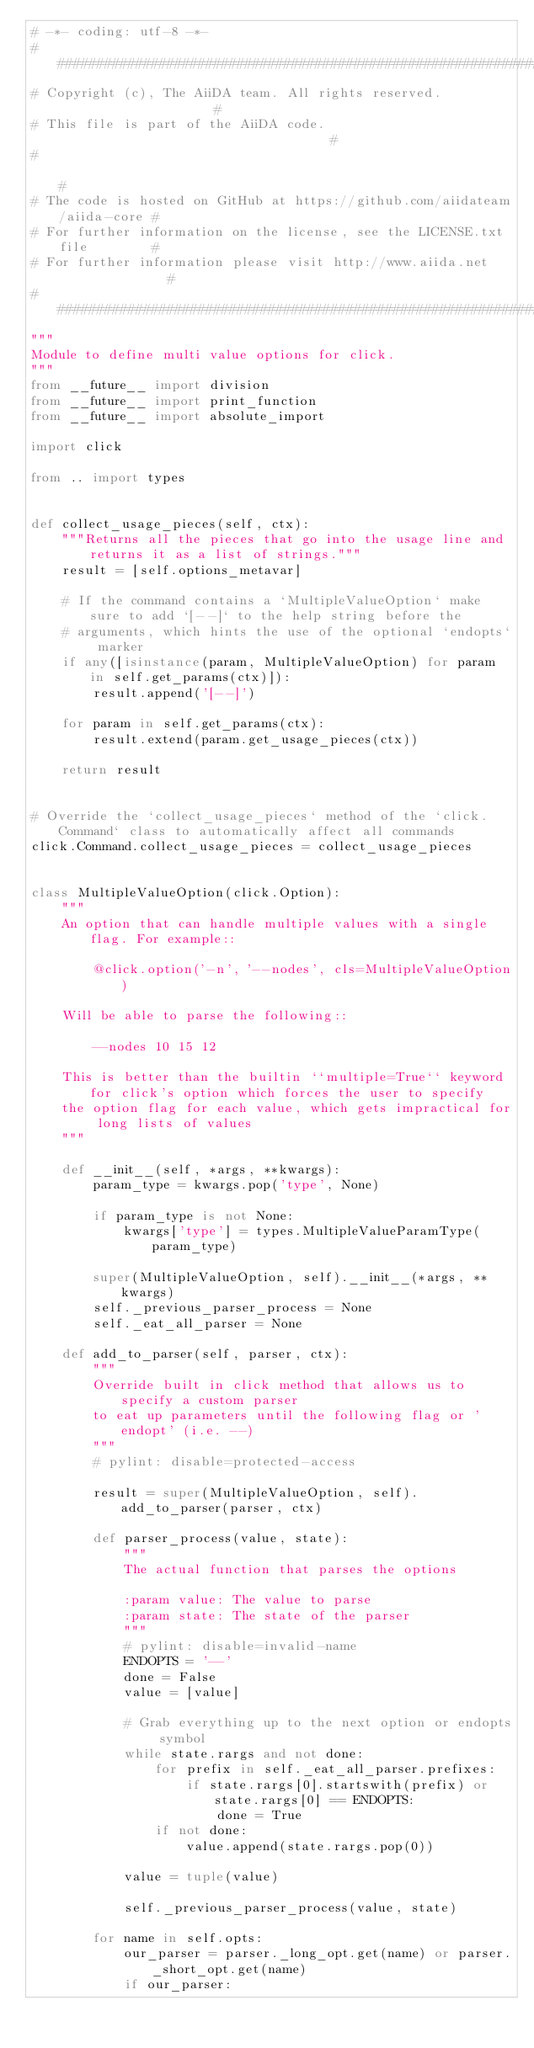<code> <loc_0><loc_0><loc_500><loc_500><_Python_># -*- coding: utf-8 -*-
###########################################################################
# Copyright (c), The AiiDA team. All rights reserved.                     #
# This file is part of the AiiDA code.                                    #
#                                                                         #
# The code is hosted on GitHub at https://github.com/aiidateam/aiida-core #
# For further information on the license, see the LICENSE.txt file        #
# For further information please visit http://www.aiida.net               #
###########################################################################
"""
Module to define multi value options for click.
"""
from __future__ import division
from __future__ import print_function
from __future__ import absolute_import

import click

from .. import types


def collect_usage_pieces(self, ctx):
    """Returns all the pieces that go into the usage line and returns it as a list of strings."""
    result = [self.options_metavar]

    # If the command contains a `MultipleValueOption` make sure to add `[--]` to the help string before the
    # arguments, which hints the use of the optional `endopts` marker
    if any([isinstance(param, MultipleValueOption) for param in self.get_params(ctx)]):
        result.append('[--]')

    for param in self.get_params(ctx):
        result.extend(param.get_usage_pieces(ctx))

    return result


# Override the `collect_usage_pieces` method of the `click.Command` class to automatically affect all commands
click.Command.collect_usage_pieces = collect_usage_pieces


class MultipleValueOption(click.Option):
    """
    An option that can handle multiple values with a single flag. For example::

        @click.option('-n', '--nodes', cls=MultipleValueOption)

    Will be able to parse the following::

        --nodes 10 15 12

    This is better than the builtin ``multiple=True`` keyword for click's option which forces the user to specify
    the option flag for each value, which gets impractical for long lists of values
    """

    def __init__(self, *args, **kwargs):
        param_type = kwargs.pop('type', None)

        if param_type is not None:
            kwargs['type'] = types.MultipleValueParamType(param_type)

        super(MultipleValueOption, self).__init__(*args, **kwargs)
        self._previous_parser_process = None
        self._eat_all_parser = None

    def add_to_parser(self, parser, ctx):
        """
        Override built in click method that allows us to specify a custom parser
        to eat up parameters until the following flag or 'endopt' (i.e. --)
        """
        # pylint: disable=protected-access

        result = super(MultipleValueOption, self).add_to_parser(parser, ctx)

        def parser_process(value, state):
            """
            The actual function that parses the options

            :param value: The value to parse
            :param state: The state of the parser
            """
            # pylint: disable=invalid-name
            ENDOPTS = '--'
            done = False
            value = [value]

            # Grab everything up to the next option or endopts symbol
            while state.rargs and not done:
                for prefix in self._eat_all_parser.prefixes:
                    if state.rargs[0].startswith(prefix) or state.rargs[0] == ENDOPTS:
                        done = True
                if not done:
                    value.append(state.rargs.pop(0))

            value = tuple(value)

            self._previous_parser_process(value, state)

        for name in self.opts:
            our_parser = parser._long_opt.get(name) or parser._short_opt.get(name)
            if our_parser:</code> 